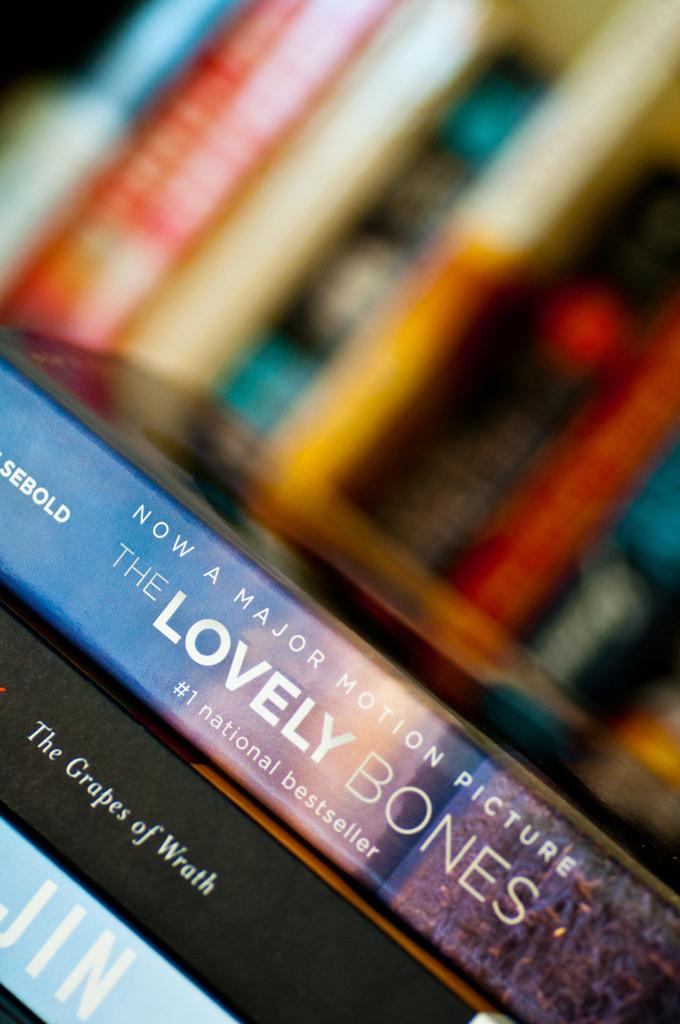What is the book name in the middle?
Make the answer very short. The grapes of wrath. 